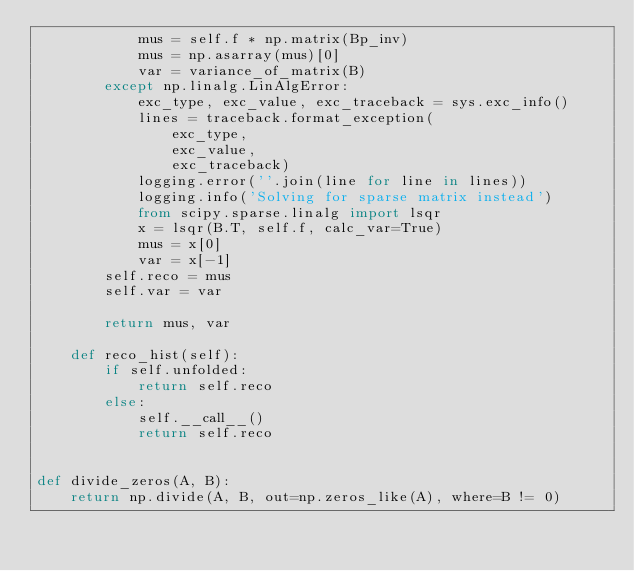Convert code to text. <code><loc_0><loc_0><loc_500><loc_500><_Python_>            mus = self.f * np.matrix(Bp_inv)
            mus = np.asarray(mus)[0]
            var = variance_of_matrix(B)
        except np.linalg.LinAlgError:
            exc_type, exc_value, exc_traceback = sys.exc_info()
            lines = traceback.format_exception(
                exc_type,
                exc_value,
                exc_traceback)
            logging.error(''.join(line for line in lines))
            logging.info('Solving for sparse matrix instead')
            from scipy.sparse.linalg import lsqr
            x = lsqr(B.T, self.f, calc_var=True)
            mus = x[0]
            var = x[-1]
        self.reco = mus
        self.var = var

        return mus, var

    def reco_hist(self):
        if self.unfolded:
            return self.reco
        else:
            self.__call__()
            return self.reco


def divide_zeros(A, B):
    return np.divide(A, B, out=np.zeros_like(A), where=B != 0)
</code> 